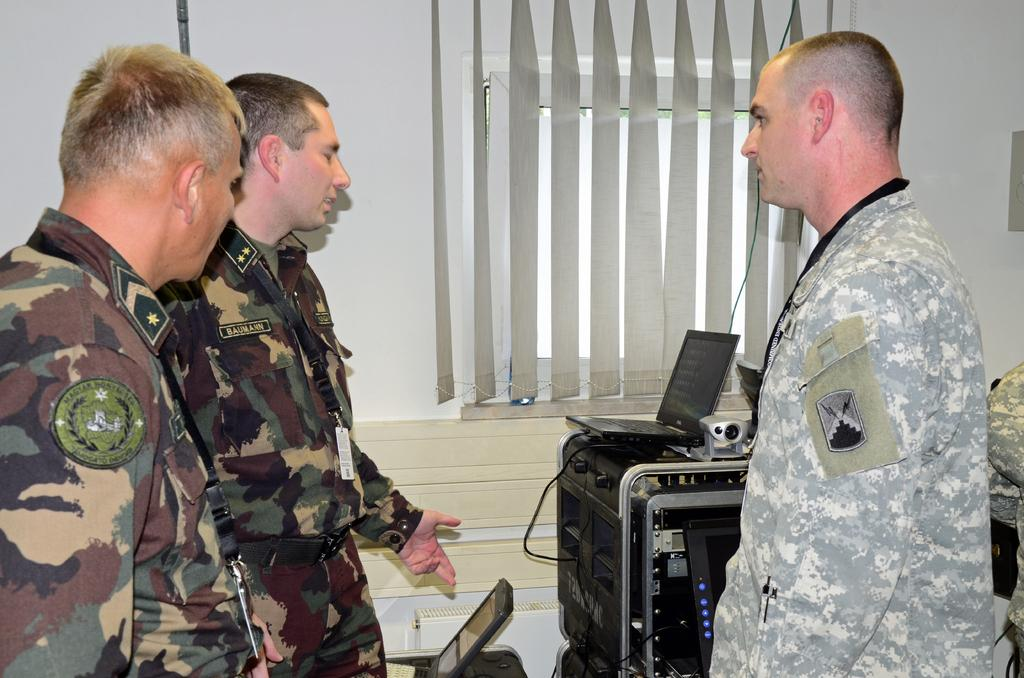What is the color of the wall in the image? The wall in the image is white. What can be seen covering the window in the image? There is a window blind in the image. What electronic devices are visible in the image? A laptop and a tablet are visible in the image. What are the three persons in the image wearing? The three persons in the image are wearing army dresses. What type of thread is being used to sew the pigs in the image? There are no pigs present in the image, and therefore no thread or sewing can be observed. How many ice cubes are visible in the image? There is no ice visible in the image. 